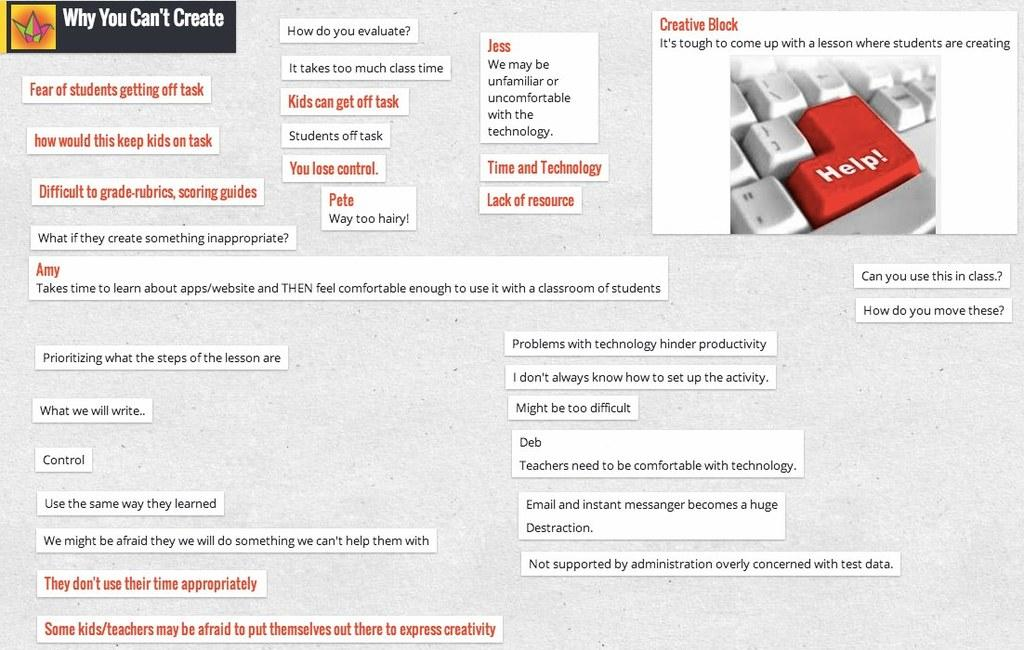<image>
Write a terse but informative summary of the picture. Why You Can't Create is the header of this collage page. 